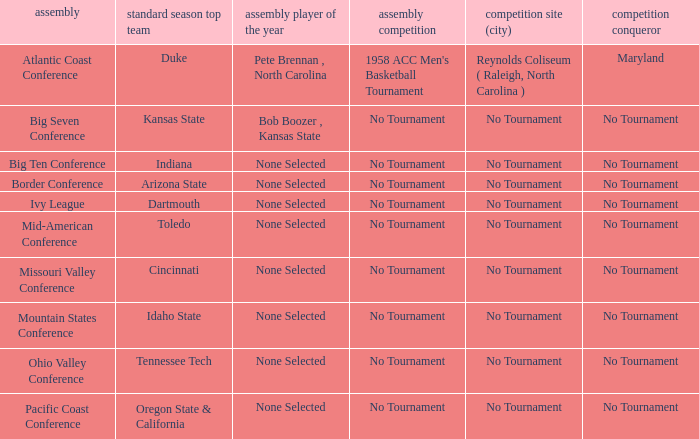Who is the tournament winner in the Atlantic Coast Conference? Maryland. 